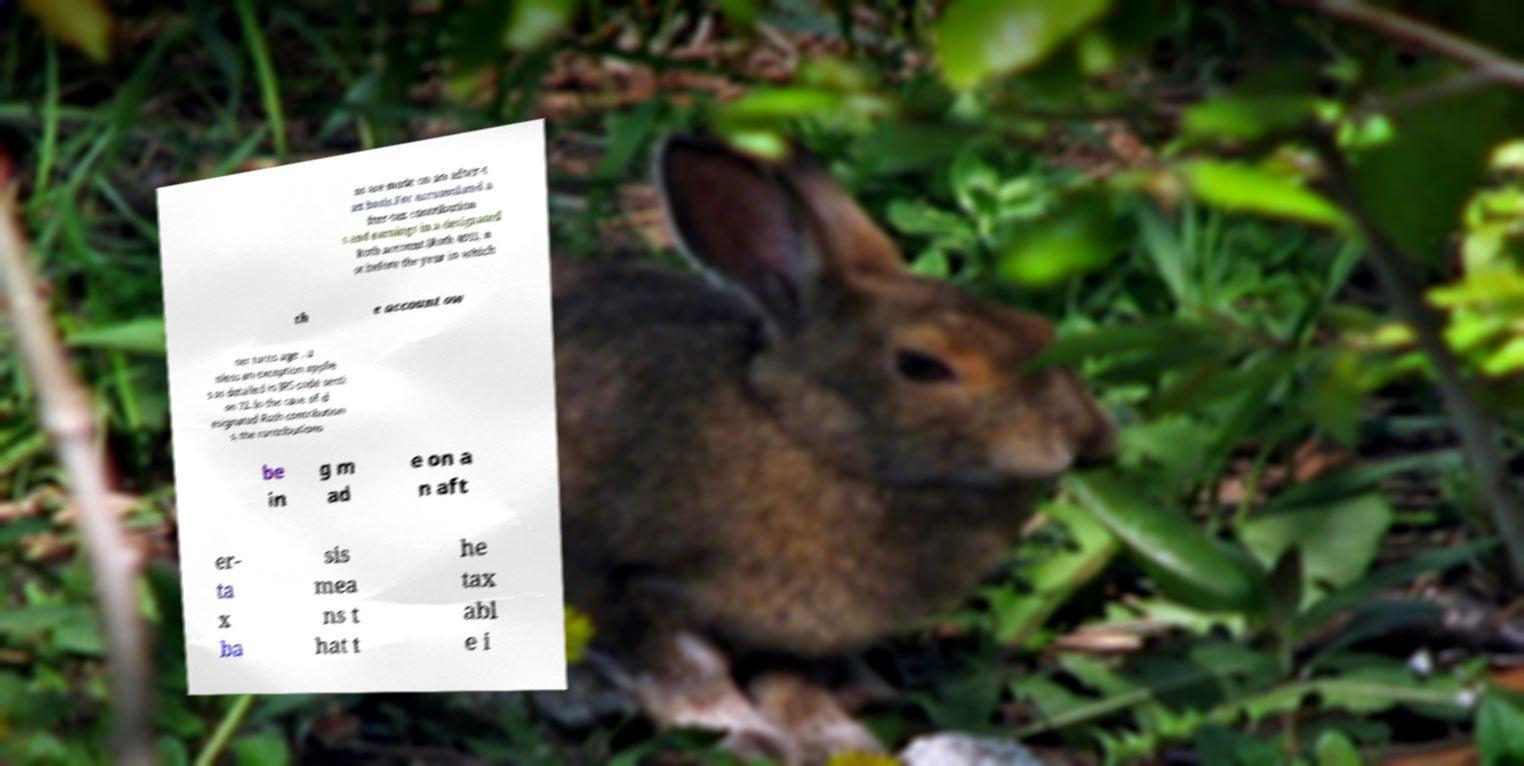Can you read and provide the text displayed in the image?This photo seems to have some interesting text. Can you extract and type it out for me? ns are made on an after-t ax basis.For accumulated a fter-tax contribution s and earnings in a designated Roth account (Roth 401), n ot before the year in which th e account ow ner turns age , u nless an exception applie s as detailed in IRS code secti on 72. In the case of d esignated Roth contribution s, the contributions be in g m ad e on a n aft er- ta x ba sis mea ns t hat t he tax abl e i 